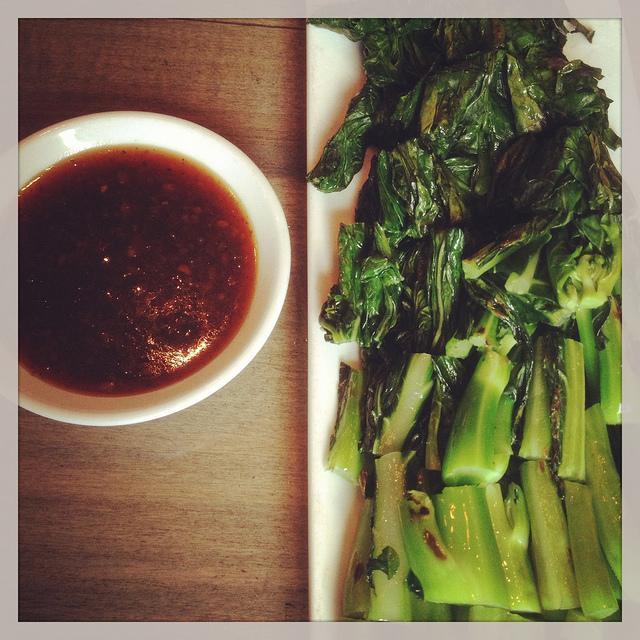What is about to be dipped?
From the following four choices, select the correct answer to address the question.
Options: Cheese, broccoli, dunkaroos, swimmer. Broccoli. 